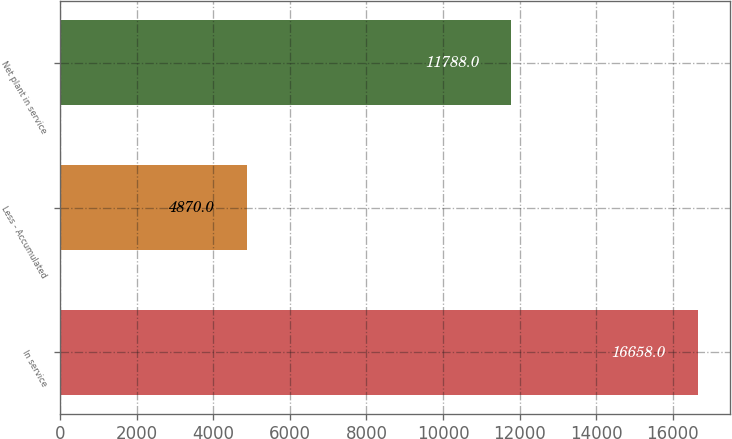Convert chart to OTSL. <chart><loc_0><loc_0><loc_500><loc_500><bar_chart><fcel>In service<fcel>Less - Accumulated<fcel>Net plant in service<nl><fcel>16658<fcel>4870<fcel>11788<nl></chart> 